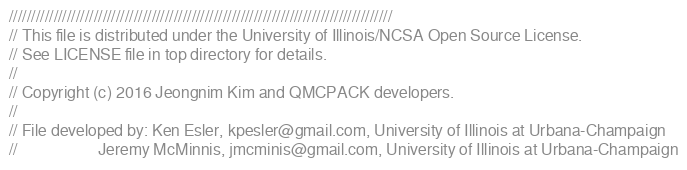Convert code to text. <code><loc_0><loc_0><loc_500><loc_500><_Cuda_>//////////////////////////////////////////////////////////////////////////////////////
// This file is distributed under the University of Illinois/NCSA Open Source License.
// See LICENSE file in top directory for details.
//
// Copyright (c) 2016 Jeongnim Kim and QMCPACK developers.
//
// File developed by: Ken Esler, kpesler@gmail.com, University of Illinois at Urbana-Champaign
//                    Jeremy McMinnis, jmcminis@gmail.com, University of Illinois at Urbana-Champaign</code> 